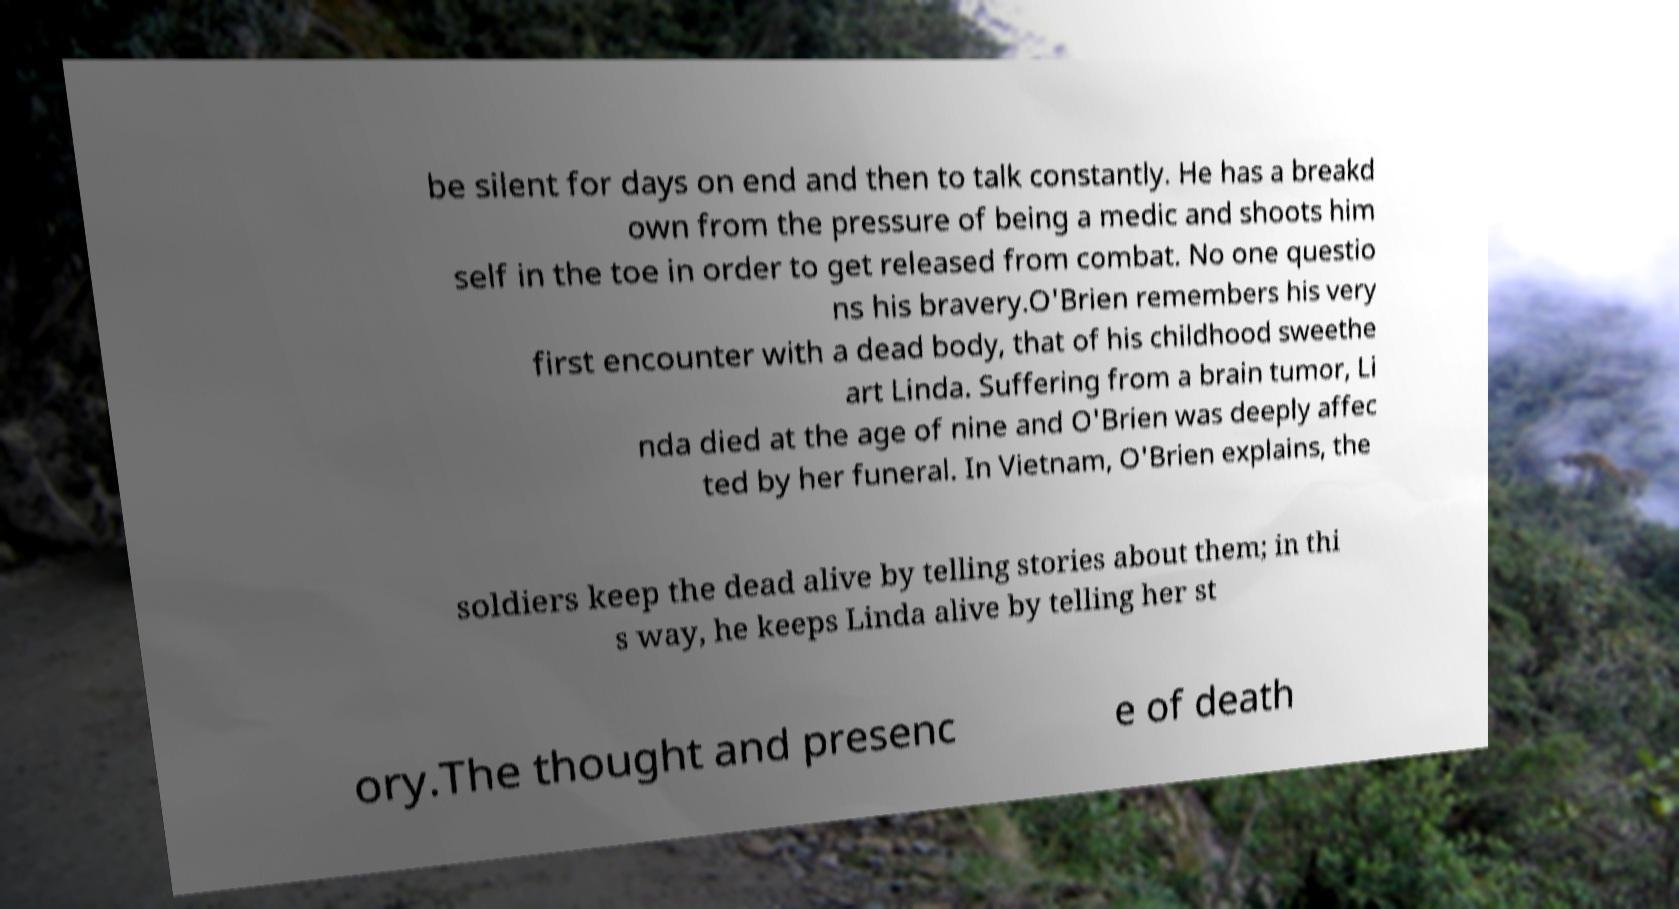Please identify and transcribe the text found in this image. be silent for days on end and then to talk constantly. He has a breakd own from the pressure of being a medic and shoots him self in the toe in order to get released from combat. No one questio ns his bravery.O'Brien remembers his very first encounter with a dead body, that of his childhood sweethe art Linda. Suffering from a brain tumor, Li nda died at the age of nine and O'Brien was deeply affec ted by her funeral. In Vietnam, O'Brien explains, the soldiers keep the dead alive by telling stories about them; in thi s way, he keeps Linda alive by telling her st ory.The thought and presenc e of death 